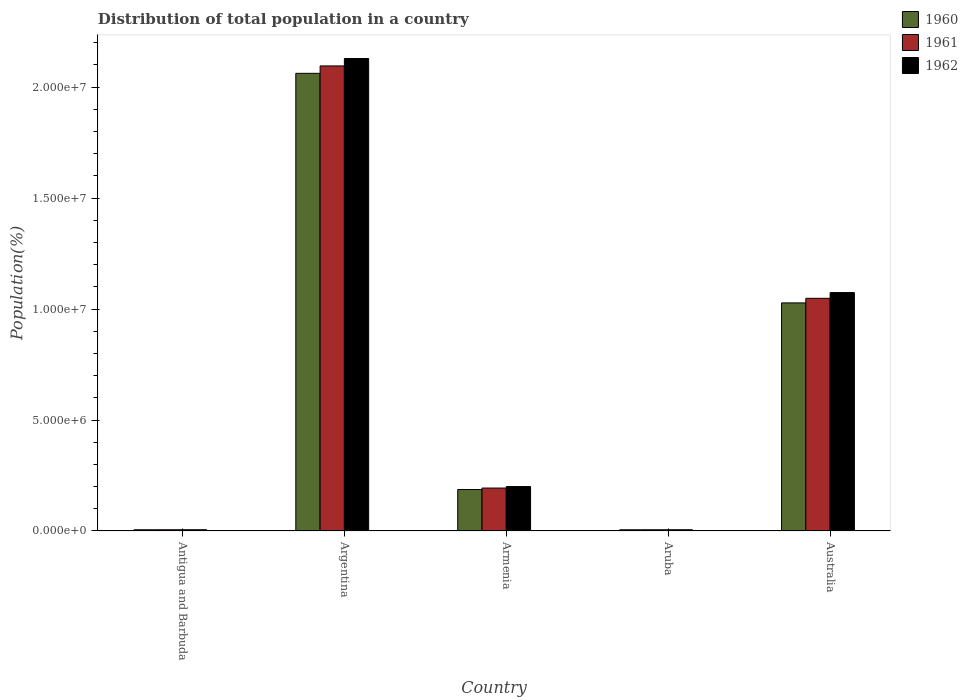How many groups of bars are there?
Give a very brief answer. 5. Are the number of bars per tick equal to the number of legend labels?
Provide a succinct answer. Yes. Are the number of bars on each tick of the X-axis equal?
Provide a succinct answer. Yes. How many bars are there on the 3rd tick from the left?
Your answer should be compact. 3. What is the label of the 5th group of bars from the left?
Your answer should be compact. Australia. What is the population of in 1962 in Australia?
Your response must be concise. 1.07e+07. Across all countries, what is the maximum population of in 1962?
Give a very brief answer. 2.13e+07. Across all countries, what is the minimum population of in 1961?
Provide a succinct answer. 5.54e+04. In which country was the population of in 1961 minimum?
Offer a terse response. Antigua and Barbuda. What is the total population of in 1961 in the graph?
Make the answer very short. 3.35e+07. What is the difference between the population of in 1960 in Armenia and that in Aruba?
Give a very brief answer. 1.81e+06. What is the difference between the population of in 1960 in Australia and the population of in 1961 in Argentina?
Make the answer very short. -1.07e+07. What is the average population of in 1960 per country?
Keep it short and to the point. 6.57e+06. What is the difference between the population of of/in 1962 and population of of/in 1960 in Argentina?
Keep it short and to the point. 6.69e+05. In how many countries, is the population of in 1960 greater than 10000000 %?
Your response must be concise. 2. What is the ratio of the population of in 1960 in Antigua and Barbuda to that in Aruba?
Provide a short and direct response. 1.01. Is the difference between the population of in 1962 in Antigua and Barbuda and Australia greater than the difference between the population of in 1960 in Antigua and Barbuda and Australia?
Offer a terse response. No. What is the difference between the highest and the second highest population of in 1962?
Your answer should be very brief. -1.05e+07. What is the difference between the highest and the lowest population of in 1962?
Ensure brevity in your answer.  2.12e+07. In how many countries, is the population of in 1962 greater than the average population of in 1962 taken over all countries?
Give a very brief answer. 2. Is the sum of the population of in 1960 in Argentina and Australia greater than the maximum population of in 1962 across all countries?
Offer a terse response. Yes. What does the 3rd bar from the right in Antigua and Barbuda represents?
Keep it short and to the point. 1960. Is it the case that in every country, the sum of the population of in 1960 and population of in 1962 is greater than the population of in 1961?
Give a very brief answer. Yes. What is the difference between two consecutive major ticks on the Y-axis?
Offer a very short reply. 5.00e+06. Are the values on the major ticks of Y-axis written in scientific E-notation?
Your answer should be compact. Yes. How many legend labels are there?
Your answer should be very brief. 3. What is the title of the graph?
Your answer should be compact. Distribution of total population in a country. Does "2015" appear as one of the legend labels in the graph?
Make the answer very short. No. What is the label or title of the Y-axis?
Offer a terse response. Population(%). What is the Population(%) in 1960 in Antigua and Barbuda?
Your response must be concise. 5.47e+04. What is the Population(%) of 1961 in Antigua and Barbuda?
Your answer should be very brief. 5.54e+04. What is the Population(%) in 1962 in Antigua and Barbuda?
Ensure brevity in your answer.  5.63e+04. What is the Population(%) of 1960 in Argentina?
Keep it short and to the point. 2.06e+07. What is the Population(%) of 1961 in Argentina?
Offer a terse response. 2.10e+07. What is the Population(%) of 1962 in Argentina?
Ensure brevity in your answer.  2.13e+07. What is the Population(%) in 1960 in Armenia?
Ensure brevity in your answer.  1.87e+06. What is the Population(%) in 1961 in Armenia?
Keep it short and to the point. 1.93e+06. What is the Population(%) in 1962 in Armenia?
Offer a very short reply. 2.00e+06. What is the Population(%) of 1960 in Aruba?
Provide a short and direct response. 5.42e+04. What is the Population(%) in 1961 in Aruba?
Your answer should be compact. 5.54e+04. What is the Population(%) in 1962 in Aruba?
Offer a very short reply. 5.62e+04. What is the Population(%) of 1960 in Australia?
Ensure brevity in your answer.  1.03e+07. What is the Population(%) of 1961 in Australia?
Your answer should be very brief. 1.05e+07. What is the Population(%) in 1962 in Australia?
Ensure brevity in your answer.  1.07e+07. Across all countries, what is the maximum Population(%) in 1960?
Offer a very short reply. 2.06e+07. Across all countries, what is the maximum Population(%) in 1961?
Make the answer very short. 2.10e+07. Across all countries, what is the maximum Population(%) of 1962?
Offer a very short reply. 2.13e+07. Across all countries, what is the minimum Population(%) of 1960?
Give a very brief answer. 5.42e+04. Across all countries, what is the minimum Population(%) of 1961?
Offer a terse response. 5.54e+04. Across all countries, what is the minimum Population(%) in 1962?
Your response must be concise. 5.62e+04. What is the total Population(%) of 1960 in the graph?
Offer a very short reply. 3.29e+07. What is the total Population(%) of 1961 in the graph?
Make the answer very short. 3.35e+07. What is the total Population(%) of 1962 in the graph?
Ensure brevity in your answer.  3.41e+07. What is the difference between the Population(%) of 1960 in Antigua and Barbuda and that in Argentina?
Your response must be concise. -2.06e+07. What is the difference between the Population(%) of 1961 in Antigua and Barbuda and that in Argentina?
Make the answer very short. -2.09e+07. What is the difference between the Population(%) of 1962 in Antigua and Barbuda and that in Argentina?
Give a very brief answer. -2.12e+07. What is the difference between the Population(%) in 1960 in Antigua and Barbuda and that in Armenia?
Offer a very short reply. -1.81e+06. What is the difference between the Population(%) in 1961 in Antigua and Barbuda and that in Armenia?
Offer a very short reply. -1.88e+06. What is the difference between the Population(%) in 1962 in Antigua and Barbuda and that in Armenia?
Offer a very short reply. -1.95e+06. What is the difference between the Population(%) in 1960 in Antigua and Barbuda and that in Aruba?
Offer a very short reply. 473. What is the difference between the Population(%) of 1961 in Antigua and Barbuda and that in Aruba?
Your answer should be very brief. -32. What is the difference between the Population(%) of 1962 in Antigua and Barbuda and that in Aruba?
Your answer should be compact. 85. What is the difference between the Population(%) in 1960 in Antigua and Barbuda and that in Australia?
Provide a succinct answer. -1.02e+07. What is the difference between the Population(%) in 1961 in Antigua and Barbuda and that in Australia?
Your answer should be compact. -1.04e+07. What is the difference between the Population(%) of 1962 in Antigua and Barbuda and that in Australia?
Your answer should be very brief. -1.07e+07. What is the difference between the Population(%) of 1960 in Argentina and that in Armenia?
Keep it short and to the point. 1.88e+07. What is the difference between the Population(%) of 1961 in Argentina and that in Armenia?
Provide a succinct answer. 1.90e+07. What is the difference between the Population(%) of 1962 in Argentina and that in Armenia?
Give a very brief answer. 1.93e+07. What is the difference between the Population(%) in 1960 in Argentina and that in Aruba?
Give a very brief answer. 2.06e+07. What is the difference between the Population(%) of 1961 in Argentina and that in Aruba?
Your answer should be very brief. 2.09e+07. What is the difference between the Population(%) of 1962 in Argentina and that in Aruba?
Provide a short and direct response. 2.12e+07. What is the difference between the Population(%) of 1960 in Argentina and that in Australia?
Offer a terse response. 1.03e+07. What is the difference between the Population(%) in 1961 in Argentina and that in Australia?
Ensure brevity in your answer.  1.05e+07. What is the difference between the Population(%) in 1962 in Argentina and that in Australia?
Provide a short and direct response. 1.05e+07. What is the difference between the Population(%) of 1960 in Armenia and that in Aruba?
Your response must be concise. 1.81e+06. What is the difference between the Population(%) of 1961 in Armenia and that in Aruba?
Your response must be concise. 1.88e+06. What is the difference between the Population(%) in 1962 in Armenia and that in Aruba?
Your answer should be compact. 1.95e+06. What is the difference between the Population(%) in 1960 in Armenia and that in Australia?
Provide a succinct answer. -8.41e+06. What is the difference between the Population(%) in 1961 in Armenia and that in Australia?
Your response must be concise. -8.55e+06. What is the difference between the Population(%) of 1962 in Armenia and that in Australia?
Make the answer very short. -8.74e+06. What is the difference between the Population(%) in 1960 in Aruba and that in Australia?
Offer a terse response. -1.02e+07. What is the difference between the Population(%) in 1961 in Aruba and that in Australia?
Keep it short and to the point. -1.04e+07. What is the difference between the Population(%) in 1962 in Aruba and that in Australia?
Provide a succinct answer. -1.07e+07. What is the difference between the Population(%) of 1960 in Antigua and Barbuda and the Population(%) of 1961 in Argentina?
Make the answer very short. -2.09e+07. What is the difference between the Population(%) of 1960 in Antigua and Barbuda and the Population(%) of 1962 in Argentina?
Give a very brief answer. -2.12e+07. What is the difference between the Population(%) in 1961 in Antigua and Barbuda and the Population(%) in 1962 in Argentina?
Give a very brief answer. -2.12e+07. What is the difference between the Population(%) in 1960 in Antigua and Barbuda and the Population(%) in 1961 in Armenia?
Provide a succinct answer. -1.88e+06. What is the difference between the Population(%) of 1960 in Antigua and Barbuda and the Population(%) of 1962 in Armenia?
Ensure brevity in your answer.  -1.95e+06. What is the difference between the Population(%) of 1961 in Antigua and Barbuda and the Population(%) of 1962 in Armenia?
Your answer should be very brief. -1.95e+06. What is the difference between the Population(%) in 1960 in Antigua and Barbuda and the Population(%) in 1961 in Aruba?
Your response must be concise. -754. What is the difference between the Population(%) in 1960 in Antigua and Barbuda and the Population(%) in 1962 in Aruba?
Offer a terse response. -1545. What is the difference between the Population(%) in 1961 in Antigua and Barbuda and the Population(%) in 1962 in Aruba?
Keep it short and to the point. -823. What is the difference between the Population(%) of 1960 in Antigua and Barbuda and the Population(%) of 1961 in Australia?
Provide a succinct answer. -1.04e+07. What is the difference between the Population(%) in 1960 in Antigua and Barbuda and the Population(%) in 1962 in Australia?
Offer a very short reply. -1.07e+07. What is the difference between the Population(%) of 1961 in Antigua and Barbuda and the Population(%) of 1962 in Australia?
Provide a short and direct response. -1.07e+07. What is the difference between the Population(%) in 1960 in Argentina and the Population(%) in 1961 in Armenia?
Keep it short and to the point. 1.87e+07. What is the difference between the Population(%) in 1960 in Argentina and the Population(%) in 1962 in Armenia?
Your answer should be compact. 1.86e+07. What is the difference between the Population(%) in 1961 in Argentina and the Population(%) in 1962 in Armenia?
Your answer should be compact. 1.90e+07. What is the difference between the Population(%) in 1960 in Argentina and the Population(%) in 1961 in Aruba?
Provide a succinct answer. 2.06e+07. What is the difference between the Population(%) in 1960 in Argentina and the Population(%) in 1962 in Aruba?
Provide a short and direct response. 2.06e+07. What is the difference between the Population(%) of 1961 in Argentina and the Population(%) of 1962 in Aruba?
Your answer should be compact. 2.09e+07. What is the difference between the Population(%) of 1960 in Argentina and the Population(%) of 1961 in Australia?
Keep it short and to the point. 1.01e+07. What is the difference between the Population(%) in 1960 in Argentina and the Population(%) in 1962 in Australia?
Provide a succinct answer. 9.88e+06. What is the difference between the Population(%) in 1961 in Argentina and the Population(%) in 1962 in Australia?
Your answer should be very brief. 1.02e+07. What is the difference between the Population(%) of 1960 in Armenia and the Population(%) of 1961 in Aruba?
Offer a very short reply. 1.81e+06. What is the difference between the Population(%) in 1960 in Armenia and the Population(%) in 1962 in Aruba?
Your response must be concise. 1.81e+06. What is the difference between the Population(%) of 1961 in Armenia and the Population(%) of 1962 in Aruba?
Offer a terse response. 1.88e+06. What is the difference between the Population(%) of 1960 in Armenia and the Population(%) of 1961 in Australia?
Your answer should be very brief. -8.62e+06. What is the difference between the Population(%) of 1960 in Armenia and the Population(%) of 1962 in Australia?
Your answer should be compact. -8.87e+06. What is the difference between the Population(%) in 1961 in Armenia and the Population(%) in 1962 in Australia?
Offer a terse response. -8.81e+06. What is the difference between the Population(%) in 1960 in Aruba and the Population(%) in 1961 in Australia?
Provide a succinct answer. -1.04e+07. What is the difference between the Population(%) in 1960 in Aruba and the Population(%) in 1962 in Australia?
Offer a very short reply. -1.07e+07. What is the difference between the Population(%) in 1961 in Aruba and the Population(%) in 1962 in Australia?
Make the answer very short. -1.07e+07. What is the average Population(%) of 1960 per country?
Your response must be concise. 6.57e+06. What is the average Population(%) of 1961 per country?
Your answer should be compact. 6.70e+06. What is the average Population(%) of 1962 per country?
Ensure brevity in your answer.  6.83e+06. What is the difference between the Population(%) in 1960 and Population(%) in 1961 in Antigua and Barbuda?
Provide a succinct answer. -722. What is the difference between the Population(%) of 1960 and Population(%) of 1962 in Antigua and Barbuda?
Your answer should be compact. -1630. What is the difference between the Population(%) of 1961 and Population(%) of 1962 in Antigua and Barbuda?
Give a very brief answer. -908. What is the difference between the Population(%) in 1960 and Population(%) in 1961 in Argentina?
Your answer should be very brief. -3.34e+05. What is the difference between the Population(%) in 1960 and Population(%) in 1962 in Argentina?
Offer a very short reply. -6.69e+05. What is the difference between the Population(%) in 1961 and Population(%) in 1962 in Argentina?
Keep it short and to the point. -3.35e+05. What is the difference between the Population(%) of 1960 and Population(%) of 1961 in Armenia?
Provide a short and direct response. -6.68e+04. What is the difference between the Population(%) in 1960 and Population(%) in 1962 in Armenia?
Keep it short and to the point. -1.35e+05. What is the difference between the Population(%) of 1961 and Population(%) of 1962 in Armenia?
Your answer should be compact. -6.79e+04. What is the difference between the Population(%) of 1960 and Population(%) of 1961 in Aruba?
Provide a succinct answer. -1227. What is the difference between the Population(%) of 1960 and Population(%) of 1962 in Aruba?
Keep it short and to the point. -2018. What is the difference between the Population(%) in 1961 and Population(%) in 1962 in Aruba?
Your answer should be compact. -791. What is the difference between the Population(%) in 1960 and Population(%) in 1961 in Australia?
Give a very brief answer. -2.07e+05. What is the difference between the Population(%) of 1960 and Population(%) of 1962 in Australia?
Offer a terse response. -4.66e+05. What is the difference between the Population(%) of 1961 and Population(%) of 1962 in Australia?
Give a very brief answer. -2.59e+05. What is the ratio of the Population(%) of 1960 in Antigua and Barbuda to that in Argentina?
Offer a very short reply. 0. What is the ratio of the Population(%) of 1961 in Antigua and Barbuda to that in Argentina?
Your response must be concise. 0. What is the ratio of the Population(%) of 1962 in Antigua and Barbuda to that in Argentina?
Your answer should be compact. 0. What is the ratio of the Population(%) in 1960 in Antigua and Barbuda to that in Armenia?
Provide a short and direct response. 0.03. What is the ratio of the Population(%) in 1961 in Antigua and Barbuda to that in Armenia?
Your answer should be compact. 0.03. What is the ratio of the Population(%) in 1962 in Antigua and Barbuda to that in Armenia?
Provide a succinct answer. 0.03. What is the ratio of the Population(%) in 1960 in Antigua and Barbuda to that in Aruba?
Keep it short and to the point. 1.01. What is the ratio of the Population(%) of 1962 in Antigua and Barbuda to that in Aruba?
Your response must be concise. 1. What is the ratio of the Population(%) in 1960 in Antigua and Barbuda to that in Australia?
Keep it short and to the point. 0.01. What is the ratio of the Population(%) in 1961 in Antigua and Barbuda to that in Australia?
Your response must be concise. 0.01. What is the ratio of the Population(%) of 1962 in Antigua and Barbuda to that in Australia?
Provide a succinct answer. 0.01. What is the ratio of the Population(%) in 1960 in Argentina to that in Armenia?
Give a very brief answer. 11.04. What is the ratio of the Population(%) of 1961 in Argentina to that in Armenia?
Provide a succinct answer. 10.83. What is the ratio of the Population(%) in 1962 in Argentina to that in Armenia?
Provide a succinct answer. 10.63. What is the ratio of the Population(%) in 1960 in Argentina to that in Aruba?
Ensure brevity in your answer.  380.37. What is the ratio of the Population(%) of 1961 in Argentina to that in Aruba?
Your answer should be compact. 377.98. What is the ratio of the Population(%) of 1962 in Argentina to that in Aruba?
Your response must be concise. 378.61. What is the ratio of the Population(%) of 1960 in Argentina to that in Australia?
Your response must be concise. 2.01. What is the ratio of the Population(%) of 1961 in Argentina to that in Australia?
Provide a short and direct response. 2. What is the ratio of the Population(%) of 1962 in Argentina to that in Australia?
Offer a very short reply. 1.98. What is the ratio of the Population(%) in 1960 in Armenia to that in Aruba?
Give a very brief answer. 34.45. What is the ratio of the Population(%) of 1961 in Armenia to that in Aruba?
Provide a succinct answer. 34.89. What is the ratio of the Population(%) in 1962 in Armenia to that in Aruba?
Ensure brevity in your answer.  35.61. What is the ratio of the Population(%) of 1960 in Armenia to that in Australia?
Offer a very short reply. 0.18. What is the ratio of the Population(%) of 1961 in Armenia to that in Australia?
Your response must be concise. 0.18. What is the ratio of the Population(%) in 1962 in Armenia to that in Australia?
Keep it short and to the point. 0.19. What is the ratio of the Population(%) in 1960 in Aruba to that in Australia?
Offer a very short reply. 0.01. What is the ratio of the Population(%) of 1961 in Aruba to that in Australia?
Provide a short and direct response. 0.01. What is the ratio of the Population(%) in 1962 in Aruba to that in Australia?
Offer a very short reply. 0.01. What is the difference between the highest and the second highest Population(%) of 1960?
Keep it short and to the point. 1.03e+07. What is the difference between the highest and the second highest Population(%) in 1961?
Offer a terse response. 1.05e+07. What is the difference between the highest and the second highest Population(%) in 1962?
Offer a very short reply. 1.05e+07. What is the difference between the highest and the lowest Population(%) in 1960?
Provide a succinct answer. 2.06e+07. What is the difference between the highest and the lowest Population(%) of 1961?
Your answer should be compact. 2.09e+07. What is the difference between the highest and the lowest Population(%) in 1962?
Your answer should be very brief. 2.12e+07. 